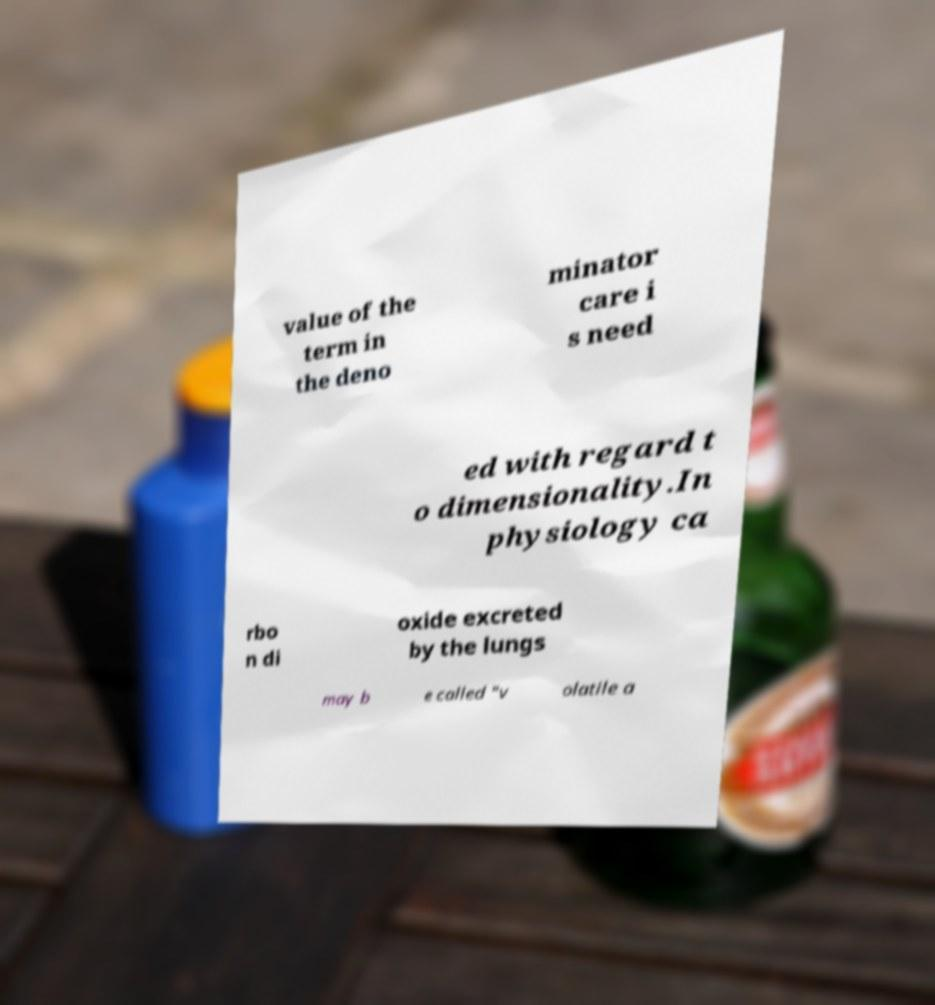For documentation purposes, I need the text within this image transcribed. Could you provide that? value of the term in the deno minator care i s need ed with regard t o dimensionality.In physiology ca rbo n di oxide excreted by the lungs may b e called "v olatile a 